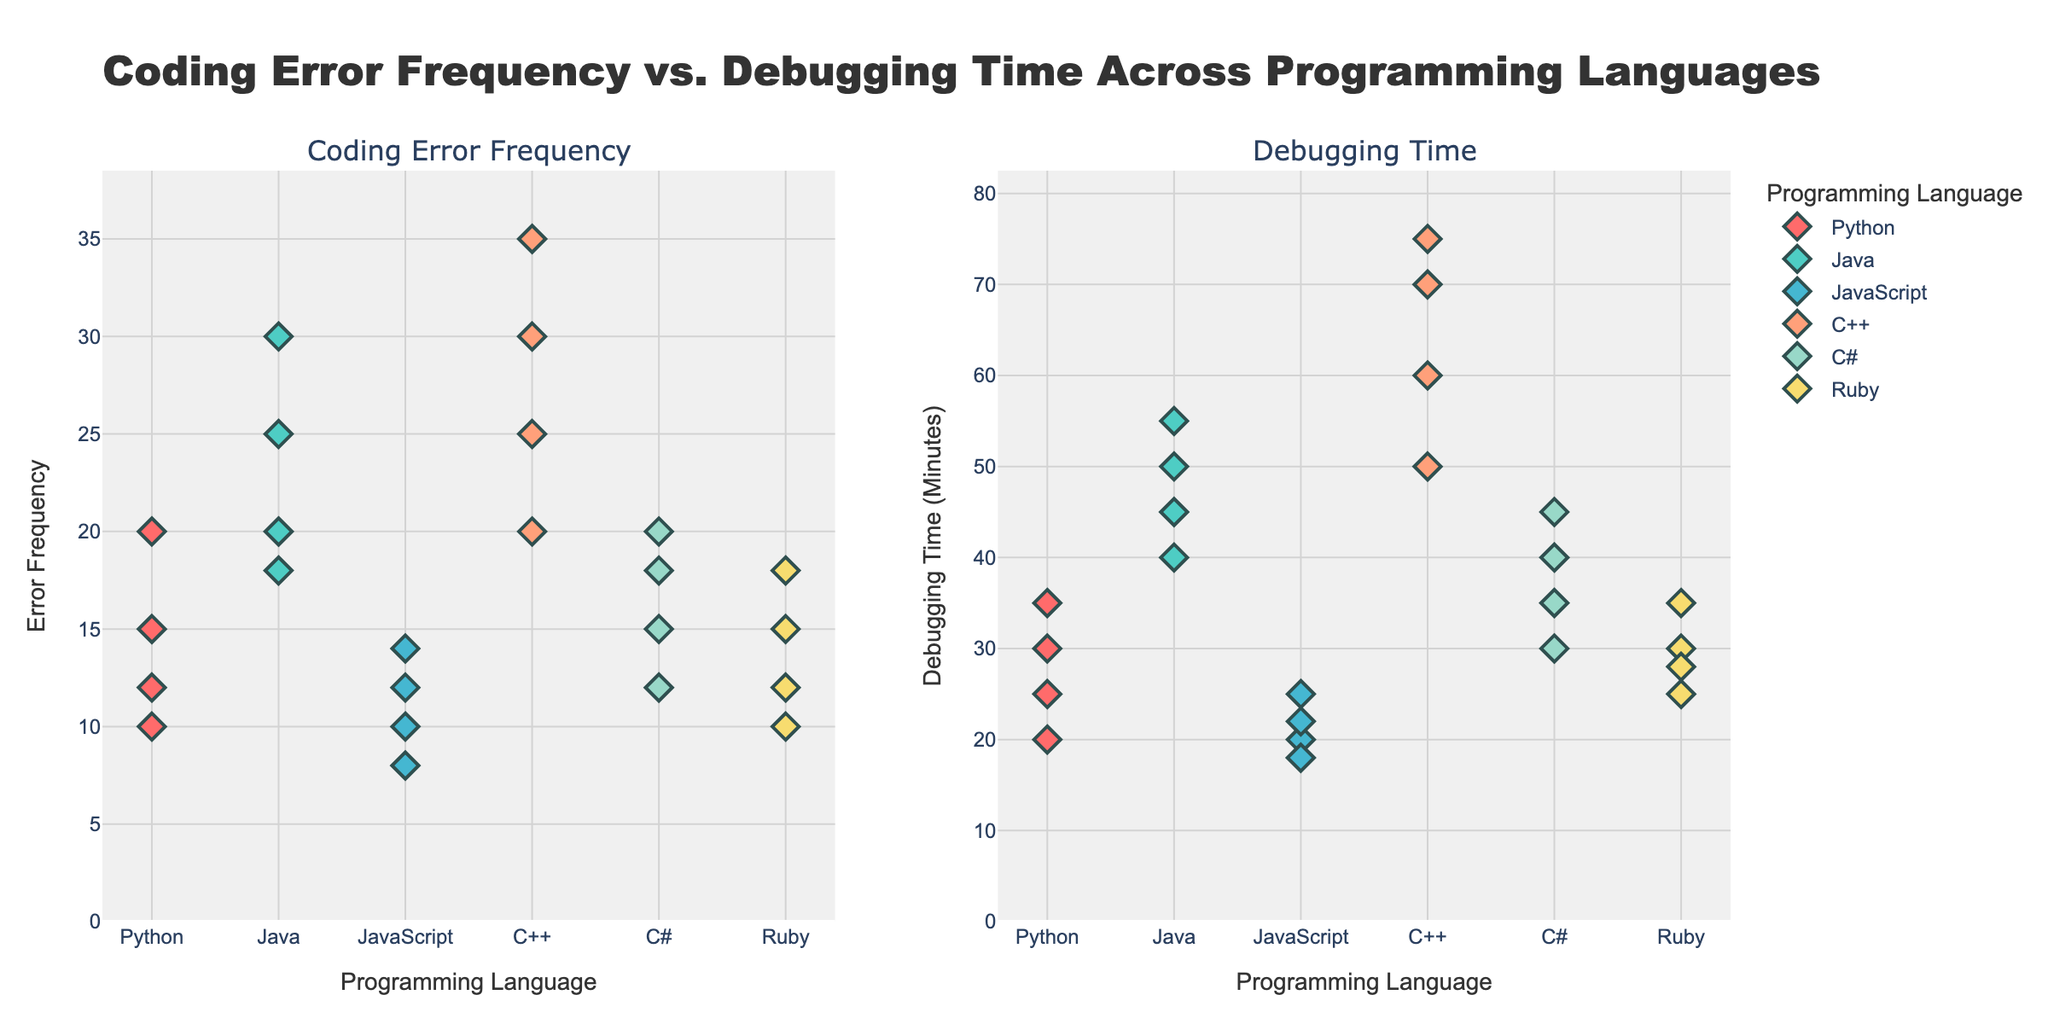What is the title of the figure? The title of the figure is usually at the top. In this case, it is stated in the `fig.update_layout` function in the code provided.
Answer: "Coding Error Frequency vs. Debugging Time Across Programming Languages" How many different programming languages are represented in the figure? The number of different programming languages can be determined from the unique values in the `Programming_Language` column in the data. Counting them gives Python, Java, JavaScript, C++, C#, and Ruby.
Answer: 6 Which programming language has the highest coding error frequency? By looking at the first subplot (Coding Error Frequency) and identifying the data point with the highest y-value, we can see C++ has the highest point at a frequency of 35.
Answer: C++ Which programming language takes the longest time to debug on average? To find this, we can observe the second subplot (Debugging Time) and estimate the average y-value for each language. C++ has the highest debugging times (50, 60, 70, and 75 minutes), which is the highest amongst the languages.
Answer: C++ What is the relationship between coding error frequency and debugging time for the same programming language? Observing the trends in both subplots, coding errors and debugging times generally increase together. For instance, higher frequencies correlate with longer debugging times for each language.
Answer: Positive correlation Which programming language has the least variation in coding error frequency? From the first subplot, we look for the language where the markers appear closest to each other vertically. Python's errors vary from 10 to 20, which shows a relatively smaller range compared to others.
Answer: Python Compare the average debugging time between Python and Ruby. Which one takes longer? By averaging the values in the second subplot for both languages: Python (30, 20, 25, 35) averages to 27.5, while Ruby averages to (25, 30, 35, 28) 29.5.
Answer: Ruby What is the average coding error frequency for Java? Adding Java's frequencies (20, 18, 25, 30) gives 93; then dividing by 4, we get 23.25 as the average.
Answer: 23.25 How does JavaScript's debugging time compare to C#? Comparing the median values can give a sense: JavaScript's times (20, 25, 18, 22) have a median of 21, while C#'s times (35, 30, 40, 45) have a median of 35.
Answer: C# has longer debugging time What's the range of debugging time for C++? The range is the difference between the highest and lowest values. For C++, the highest is 75 and the lowest is 50, so 75 - 50 = 25.
Answer: 25 